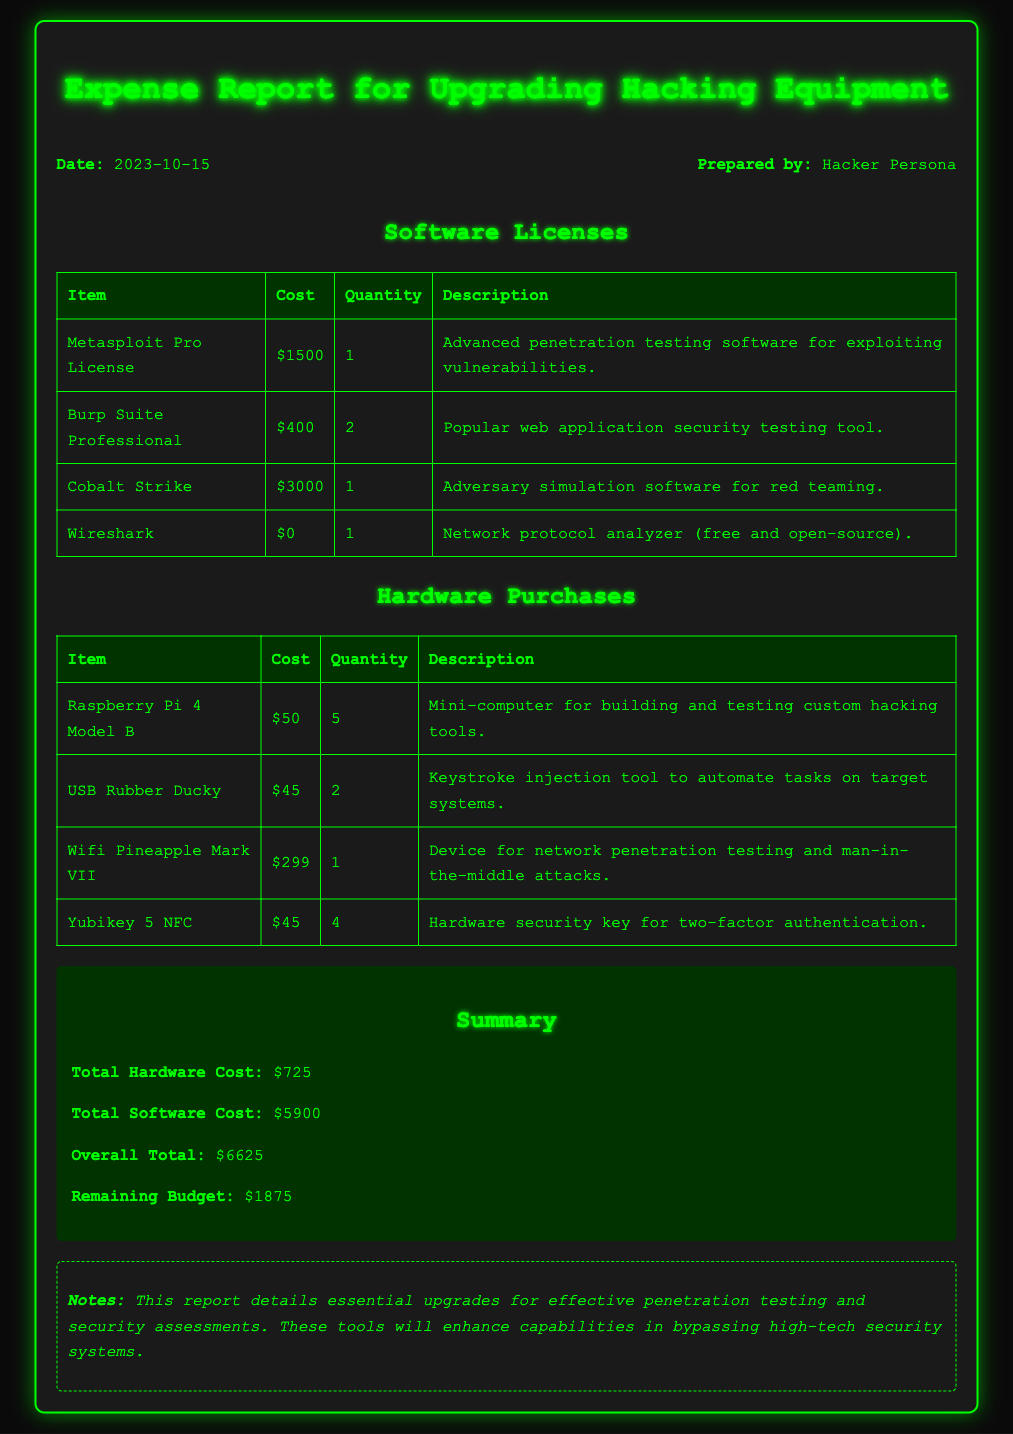what is the total software cost? The total software cost is listed in the summary section of the document, which is stated as $5900.
Answer: $5900 how many items were purchased for hardware? The hardware purchase table shows a total of four different items listed.
Answer: 4 who prepared the expense report? The header of the document indicates that the report was prepared by "Hacker Persona."
Answer: Hacker Persona what is the cost of the Raspberry Pi 4 Model B? The table under hardware purchases states the cost of the Raspberry Pi 4 Model B as $50.
Answer: $50 what is the overall total expenditure? The overall total is explicitly stated in the summary section as $6625.
Answer: $6625 what is the quantity of the USB Rubber Ducky purchased? The hardware purchases table indicates that 2 USB Rubber Duckies were bought.
Answer: 2 what is the remaining budget after the expenses? The remaining budget is mentioned in the summary section as $1875 after summarizing the costs.
Answer: $1875 which software license has the highest cost? The software section shows that Cobalt Strike has the highest cost of $3000 among the listed items.
Answer: Cobalt Strike how many Yubikey 5 NFC were purchased? The hardware purchases table indicates that 4 Yubikey 5 NFC devices were bought.
Answer: 4 